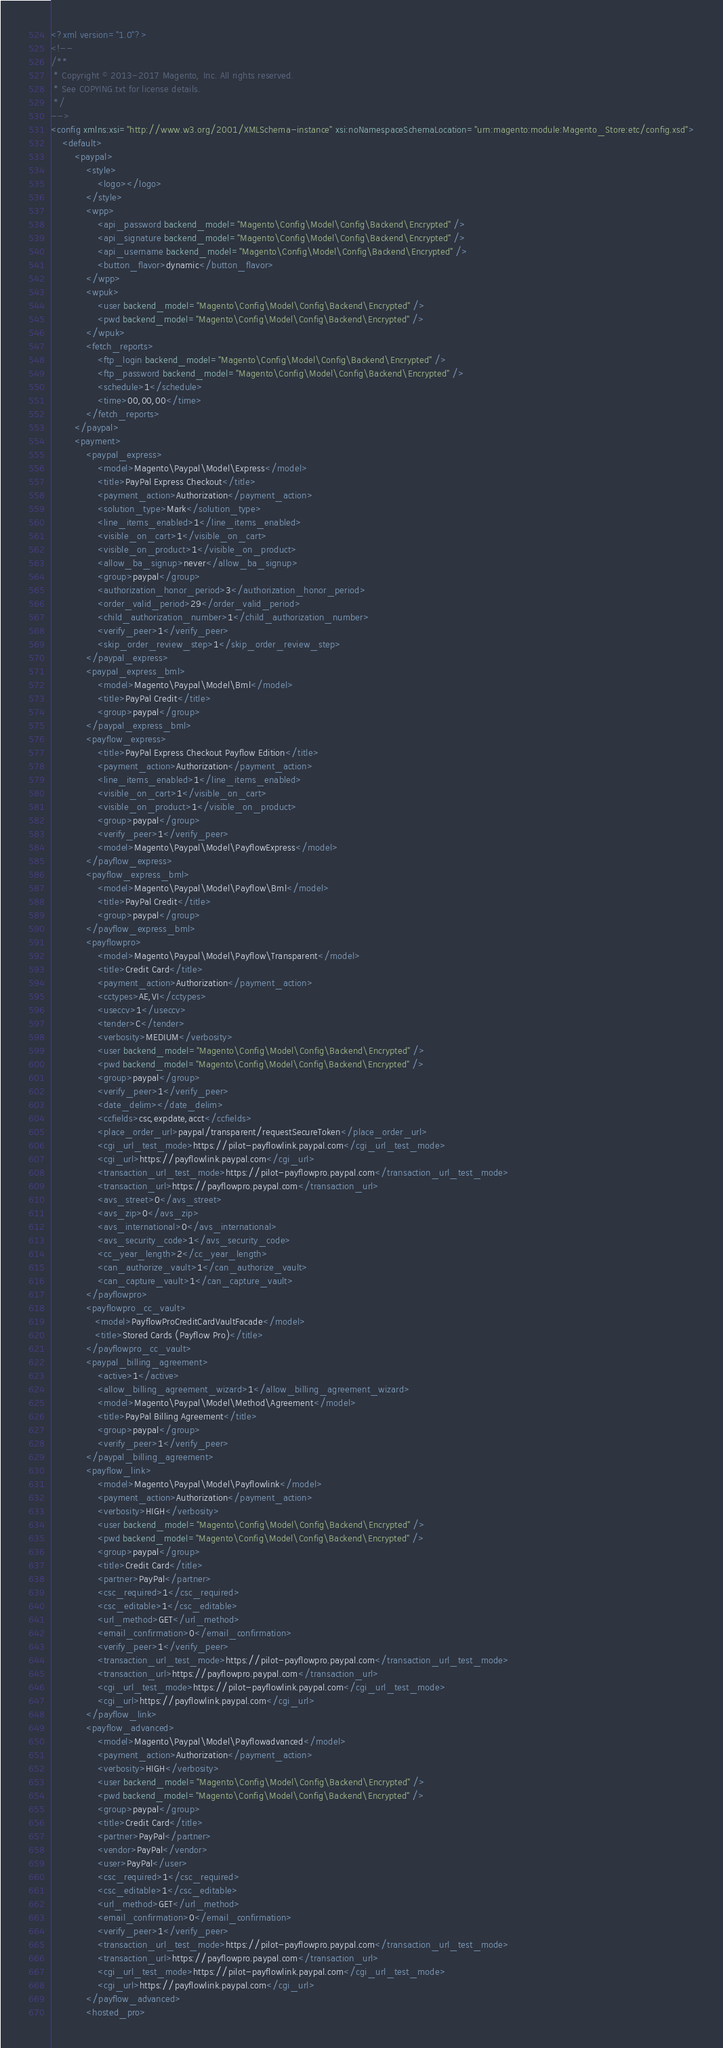Convert code to text. <code><loc_0><loc_0><loc_500><loc_500><_XML_><?xml version="1.0"?>
<!--
/**
 * Copyright © 2013-2017 Magento, Inc. All rights reserved.
 * See COPYING.txt for license details.
 */
-->
<config xmlns:xsi="http://www.w3.org/2001/XMLSchema-instance" xsi:noNamespaceSchemaLocation="urn:magento:module:Magento_Store:etc/config.xsd">
    <default>
        <paypal>
            <style>
                <logo></logo>
            </style>
            <wpp>
                <api_password backend_model="Magento\Config\Model\Config\Backend\Encrypted" />
                <api_signature backend_model="Magento\Config\Model\Config\Backend\Encrypted" />
                <api_username backend_model="Magento\Config\Model\Config\Backend\Encrypted" />
                <button_flavor>dynamic</button_flavor>
            </wpp>
            <wpuk>
                <user backend_model="Magento\Config\Model\Config\Backend\Encrypted" />
                <pwd backend_model="Magento\Config\Model\Config\Backend\Encrypted" />
            </wpuk>
            <fetch_reports>
                <ftp_login backend_model="Magento\Config\Model\Config\Backend\Encrypted" />
                <ftp_password backend_model="Magento\Config\Model\Config\Backend\Encrypted" />
                <schedule>1</schedule>
                <time>00,00,00</time>
            </fetch_reports>
        </paypal>
        <payment>
            <paypal_express>
                <model>Magento\Paypal\Model\Express</model>
                <title>PayPal Express Checkout</title>
                <payment_action>Authorization</payment_action>
                <solution_type>Mark</solution_type>
                <line_items_enabled>1</line_items_enabled>
                <visible_on_cart>1</visible_on_cart>
                <visible_on_product>1</visible_on_product>
                <allow_ba_signup>never</allow_ba_signup>
                <group>paypal</group>
                <authorization_honor_period>3</authorization_honor_period>
                <order_valid_period>29</order_valid_period>
                <child_authorization_number>1</child_authorization_number>
                <verify_peer>1</verify_peer>
                <skip_order_review_step>1</skip_order_review_step>
            </paypal_express>
            <paypal_express_bml>
                <model>Magento\Paypal\Model\Bml</model>
                <title>PayPal Credit</title>
                <group>paypal</group>
            </paypal_express_bml>
            <payflow_express>
                <title>PayPal Express Checkout Payflow Edition</title>
                <payment_action>Authorization</payment_action>
                <line_items_enabled>1</line_items_enabled>
                <visible_on_cart>1</visible_on_cart>
                <visible_on_product>1</visible_on_product>
                <group>paypal</group>
                <verify_peer>1</verify_peer>
                <model>Magento\Paypal\Model\PayflowExpress</model>
            </payflow_express>
            <payflow_express_bml>
                <model>Magento\Paypal\Model\Payflow\Bml</model>
                <title>PayPal Credit</title>
                <group>paypal</group>
            </payflow_express_bml>
            <payflowpro>
                <model>Magento\Paypal\Model\Payflow\Transparent</model>
                <title>Credit Card</title>
                <payment_action>Authorization</payment_action>
                <cctypes>AE,VI</cctypes>
                <useccv>1</useccv>
                <tender>C</tender>
                <verbosity>MEDIUM</verbosity>
                <user backend_model="Magento\Config\Model\Config\Backend\Encrypted" />
                <pwd backend_model="Magento\Config\Model\Config\Backend\Encrypted" />
                <group>paypal</group>
                <verify_peer>1</verify_peer>
                <date_delim></date_delim>
                <ccfields>csc,expdate,acct</ccfields>
                <place_order_url>paypal/transparent/requestSecureToken</place_order_url>
                <cgi_url_test_mode>https://pilot-payflowlink.paypal.com</cgi_url_test_mode>
                <cgi_url>https://payflowlink.paypal.com</cgi_url>
                <transaction_url_test_mode>https://pilot-payflowpro.paypal.com</transaction_url_test_mode>
                <transaction_url>https://payflowpro.paypal.com</transaction_url>
                <avs_street>0</avs_street>
                <avs_zip>0</avs_zip>
                <avs_international>0</avs_international>
                <avs_security_code>1</avs_security_code>
                <cc_year_length>2</cc_year_length>
                <can_authorize_vault>1</can_authorize_vault>
                <can_capture_vault>1</can_capture_vault>
            </payflowpro>
            <payflowpro_cc_vault>
               <model>PayflowProCreditCardVaultFacade</model>
               <title>Stored Cards (Payflow Pro)</title>
            </payflowpro_cc_vault>
            <paypal_billing_agreement>
                <active>1</active>
                <allow_billing_agreement_wizard>1</allow_billing_agreement_wizard>
                <model>Magento\Paypal\Model\Method\Agreement</model>
                <title>PayPal Billing Agreement</title>
                <group>paypal</group>
                <verify_peer>1</verify_peer>
            </paypal_billing_agreement>
            <payflow_link>
                <model>Magento\Paypal\Model\Payflowlink</model>
                <payment_action>Authorization</payment_action>
                <verbosity>HIGH</verbosity>
                <user backend_model="Magento\Config\Model\Config\Backend\Encrypted" />
                <pwd backend_model="Magento\Config\Model\Config\Backend\Encrypted" />
                <group>paypal</group>
                <title>Credit Card</title>
                <partner>PayPal</partner>
                <csc_required>1</csc_required>
                <csc_editable>1</csc_editable>
                <url_method>GET</url_method>
                <email_confirmation>0</email_confirmation>
                <verify_peer>1</verify_peer>
                <transaction_url_test_mode>https://pilot-payflowpro.paypal.com</transaction_url_test_mode>
                <transaction_url>https://payflowpro.paypal.com</transaction_url>
                <cgi_url_test_mode>https://pilot-payflowlink.paypal.com</cgi_url_test_mode>
                <cgi_url>https://payflowlink.paypal.com</cgi_url>
            </payflow_link>
            <payflow_advanced>
                <model>Magento\Paypal\Model\Payflowadvanced</model>
                <payment_action>Authorization</payment_action>
                <verbosity>HIGH</verbosity>
                <user backend_model="Magento\Config\Model\Config\Backend\Encrypted" />
                <pwd backend_model="Magento\Config\Model\Config\Backend\Encrypted" />
                <group>paypal</group>
                <title>Credit Card</title>
                <partner>PayPal</partner>
                <vendor>PayPal</vendor>
                <user>PayPal</user>
                <csc_required>1</csc_required>
                <csc_editable>1</csc_editable>
                <url_method>GET</url_method>
                <email_confirmation>0</email_confirmation>
                <verify_peer>1</verify_peer>
                <transaction_url_test_mode>https://pilot-payflowpro.paypal.com</transaction_url_test_mode>
                <transaction_url>https://payflowpro.paypal.com</transaction_url>
                <cgi_url_test_mode>https://pilot-payflowlink.paypal.com</cgi_url_test_mode>
                <cgi_url>https://payflowlink.paypal.com</cgi_url>
            </payflow_advanced>
            <hosted_pro></code> 